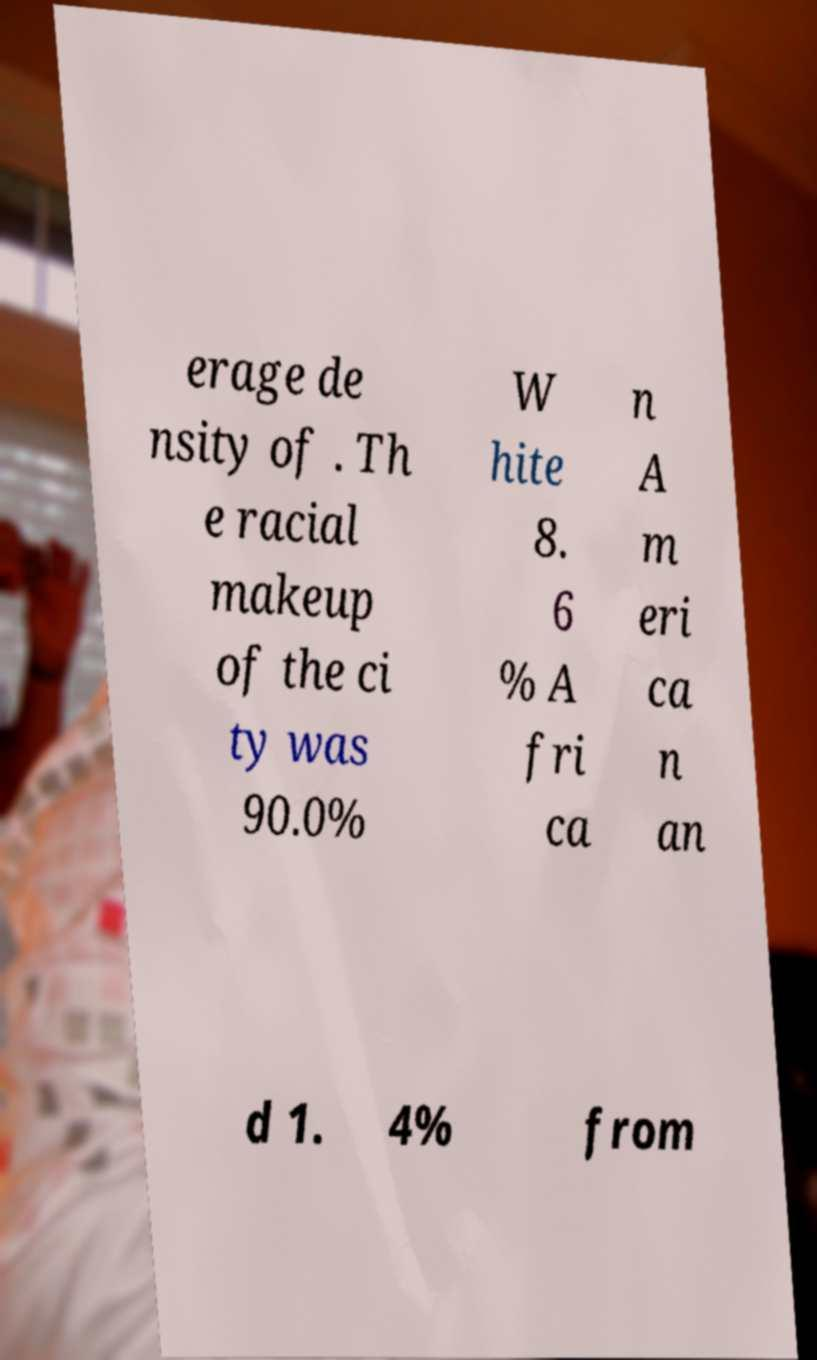What messages or text are displayed in this image? I need them in a readable, typed format. erage de nsity of . Th e racial makeup of the ci ty was 90.0% W hite 8. 6 % A fri ca n A m eri ca n an d 1. 4% from 